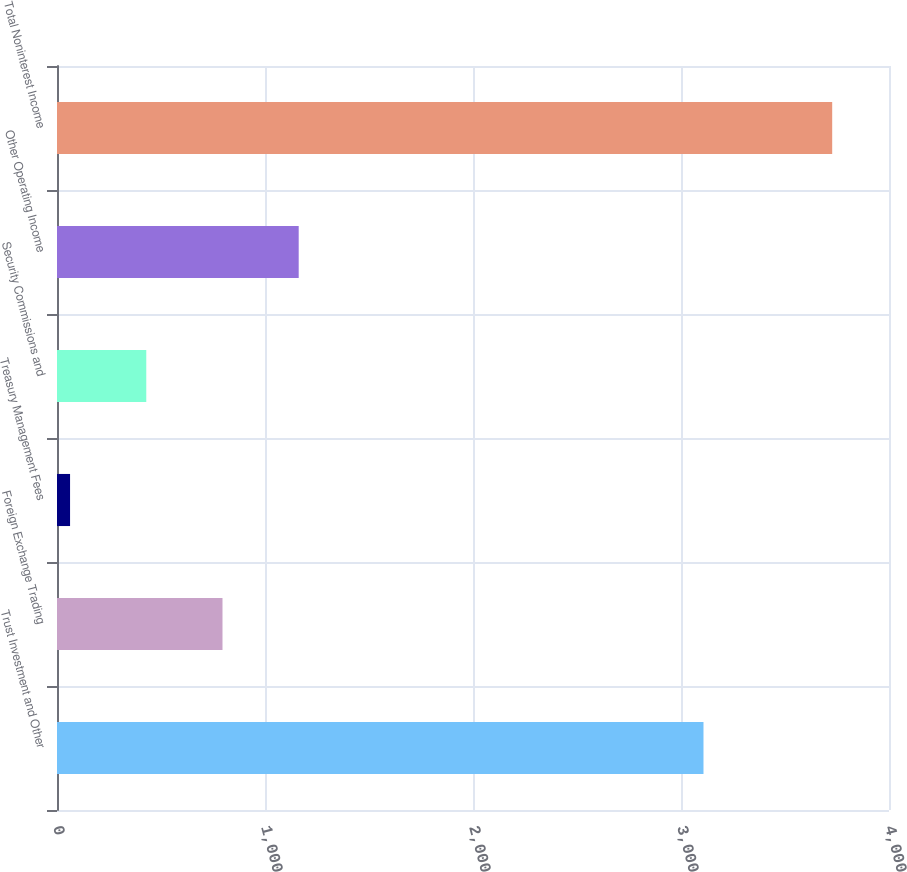<chart> <loc_0><loc_0><loc_500><loc_500><bar_chart><fcel>Trust Investment and Other<fcel>Foreign Exchange Trading<fcel>Treasury Management Fees<fcel>Security Commissions and<fcel>Other Operating Income<fcel>Total Noninterest Income<nl><fcel>3108.1<fcel>795.62<fcel>62.8<fcel>429.21<fcel>1162.03<fcel>3726.9<nl></chart> 